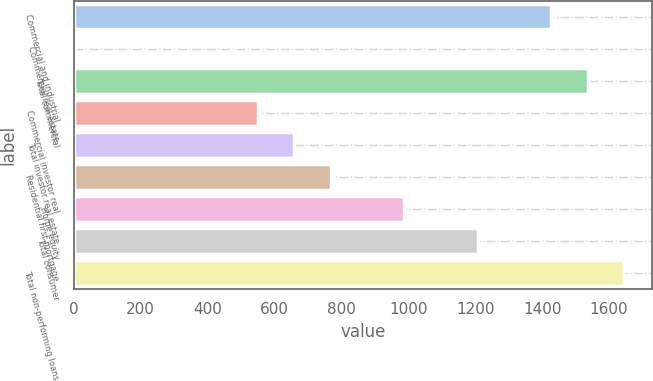Convert chart. <chart><loc_0><loc_0><loc_500><loc_500><bar_chart><fcel>Commercial and industrial<fcel>Commercial real estate<fcel>Total commercial<fcel>Commercial investor real<fcel>Total investor real estate<fcel>Residential first mortgage<fcel>Home equity<fcel>Total consumer<fcel>Total non-performing loans<nl><fcel>1426.5<fcel>3<fcel>1536<fcel>550.5<fcel>660<fcel>769.5<fcel>988.5<fcel>1207.5<fcel>1645.5<nl></chart> 